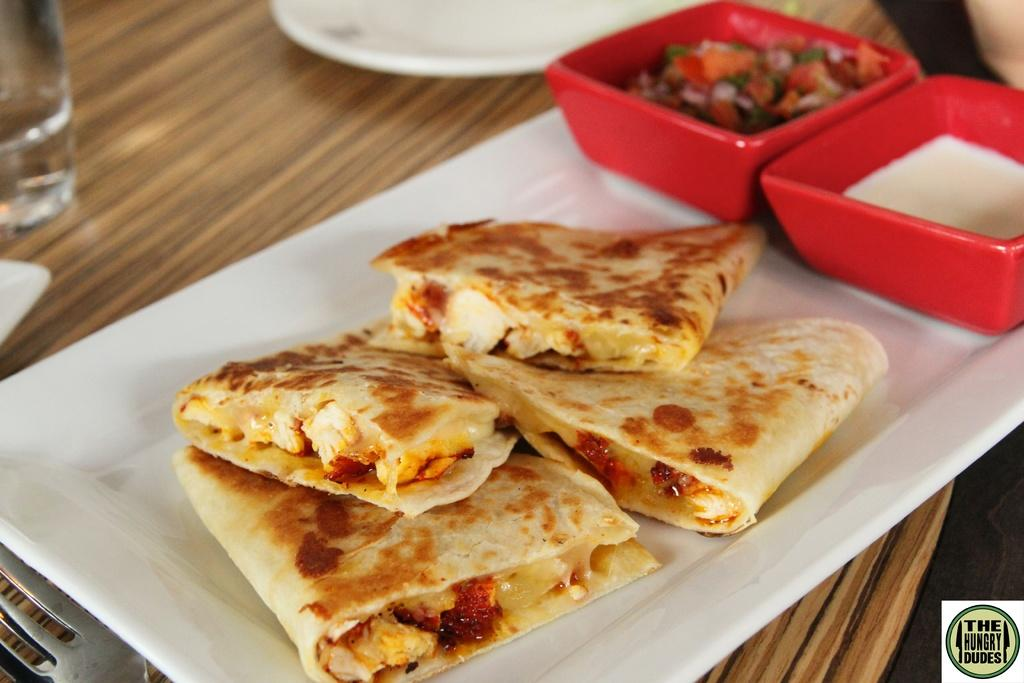What is placed on the wooden surface in the image? There is a tray on the wooden surface. What else can be seen on the wooden surface besides the tray? There is food, bowls, a plate, a glass, and a fork on the wooden surface. How many bowls are visible on the wooden surface? There are bowls on the wooden surface, but the exact number cannot be determined from the image. What type of container is present on the wooden surface? There is a glass on the wooden surface. Can you see a skate being used on the wooden surface in the image? There is no skate present on the wooden surface in the image. What type of border is visible around the wooden surface in the image? There is no border visible around the wooden surface in the image. 